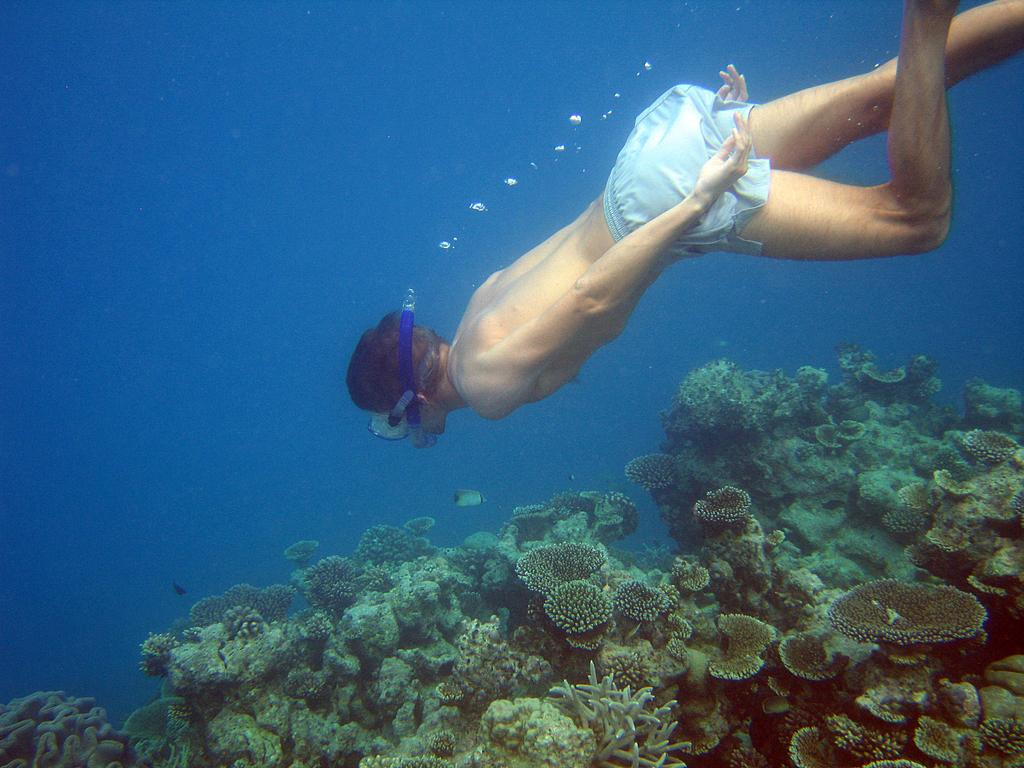What is the person in the image doing? The person is swimming in the water. What equipment is the person using while swimming? The person is wearing a snorkel. What can be seen underwater in the image? There are corals in the water. What else is visible in the water? Bubbles are present in the water. What type of crime is being committed in the image? There is no crime being committed in the image; it features a person swimming with a snorkel in water with corals and bubbles. What musical instrument can be seen in the image? There is no musical instrument present in the image. 